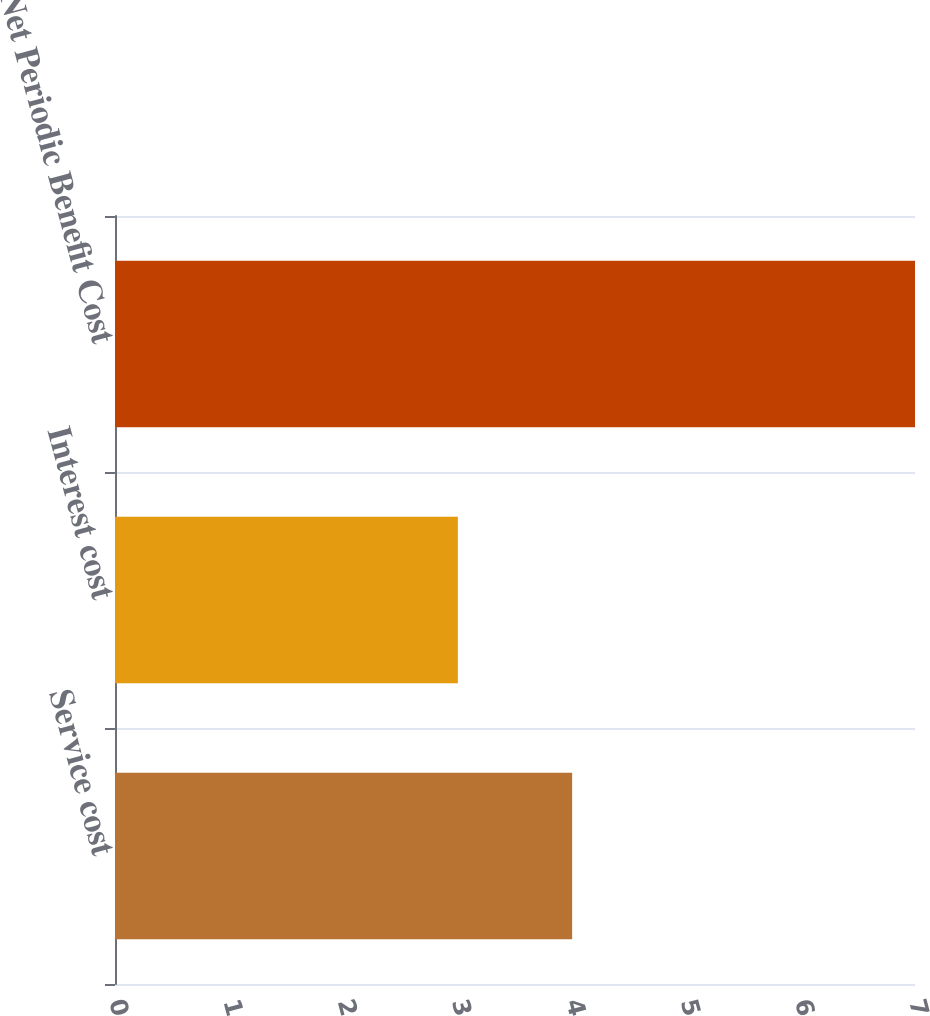<chart> <loc_0><loc_0><loc_500><loc_500><bar_chart><fcel>Service cost<fcel>Interest cost<fcel>Net Periodic Benefit Cost<nl><fcel>4<fcel>3<fcel>7<nl></chart> 